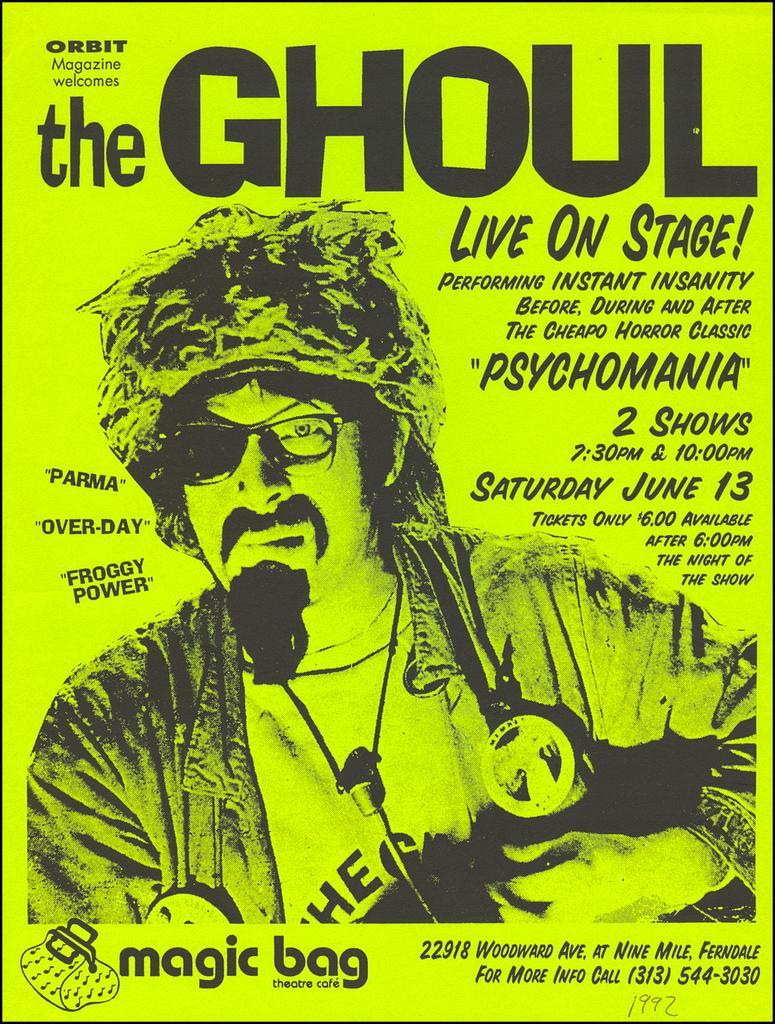Describe this image in one or two sentences. In this image we can see a poster with text, image and numbers. 